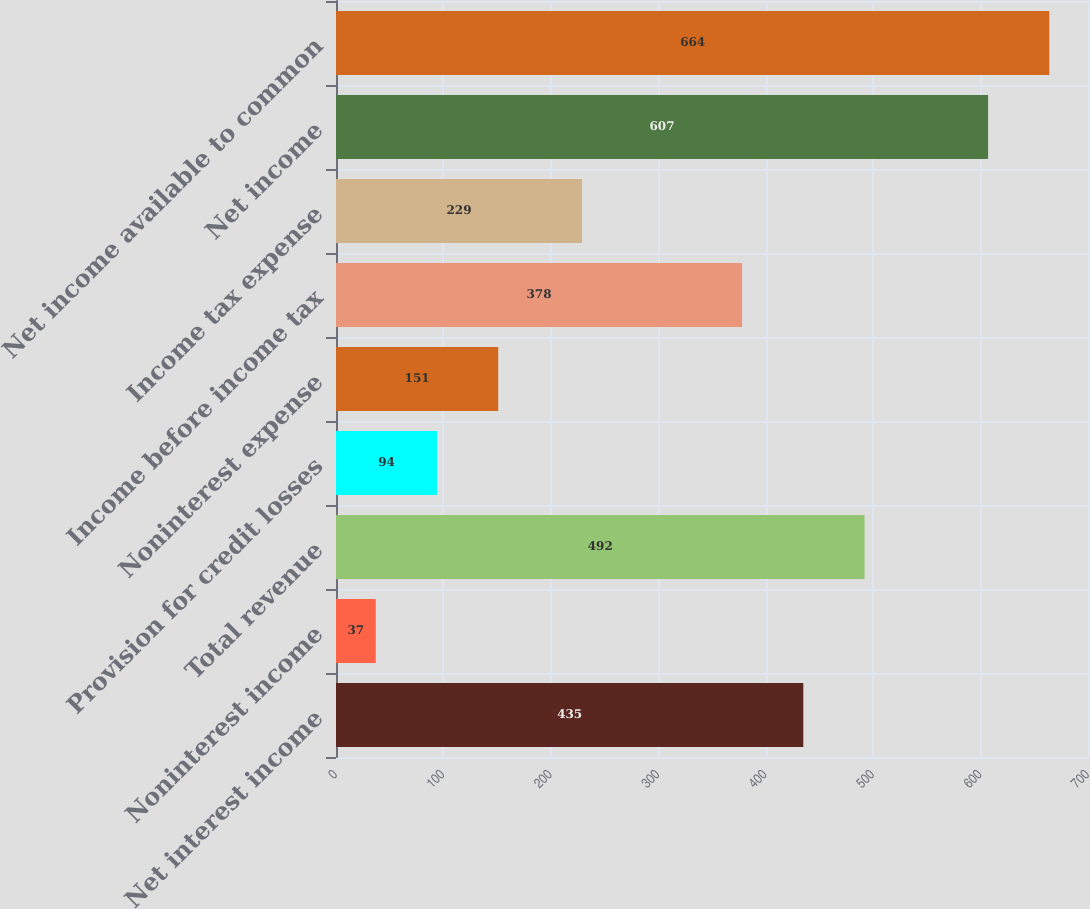Convert chart to OTSL. <chart><loc_0><loc_0><loc_500><loc_500><bar_chart><fcel>Net interest income<fcel>Noninterest income<fcel>Total revenue<fcel>Provision for credit losses<fcel>Noninterest expense<fcel>Income before income tax<fcel>Income tax expense<fcel>Net income<fcel>Net income available to common<nl><fcel>435<fcel>37<fcel>492<fcel>94<fcel>151<fcel>378<fcel>229<fcel>607<fcel>664<nl></chart> 